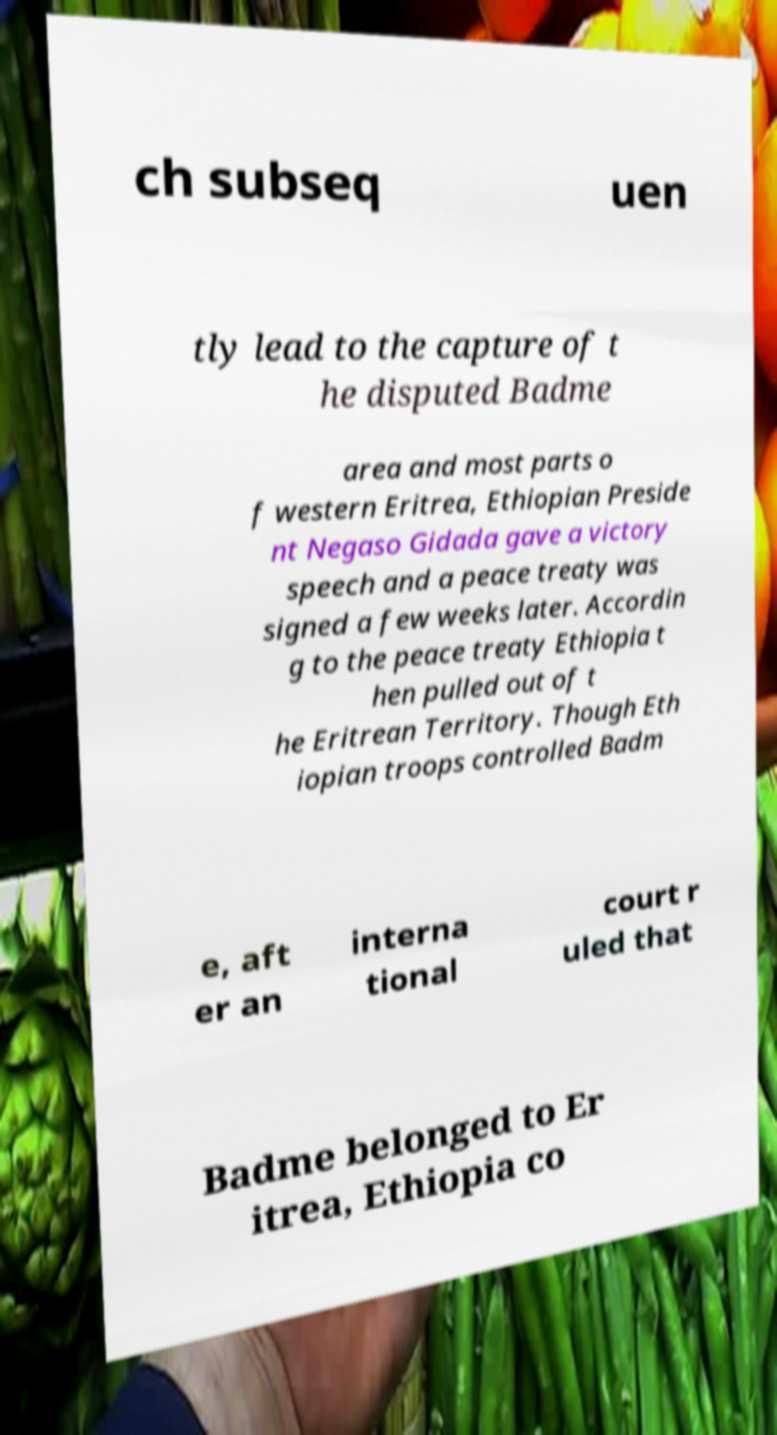Can you accurately transcribe the text from the provided image for me? ch subseq uen tly lead to the capture of t he disputed Badme area and most parts o f western Eritrea, Ethiopian Preside nt Negaso Gidada gave a victory speech and a peace treaty was signed a few weeks later. Accordin g to the peace treaty Ethiopia t hen pulled out of t he Eritrean Territory. Though Eth iopian troops controlled Badm e, aft er an interna tional court r uled that Badme belonged to Er itrea, Ethiopia co 